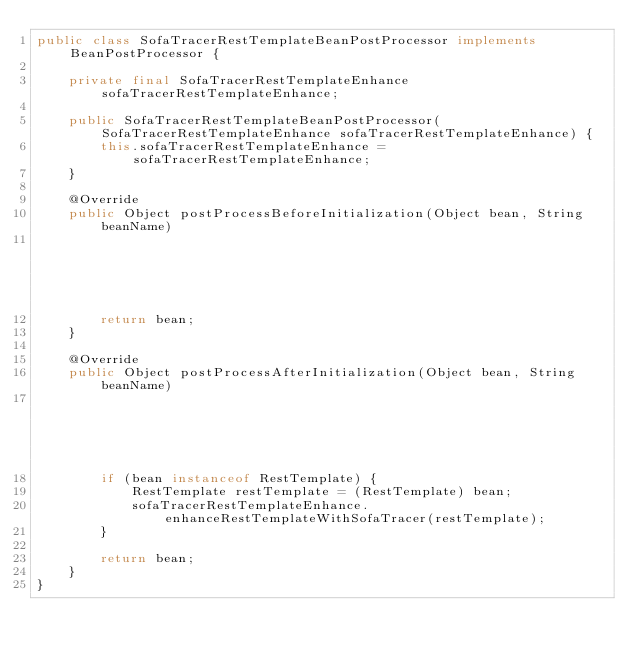Convert code to text. <code><loc_0><loc_0><loc_500><loc_500><_Java_>public class SofaTracerRestTemplateBeanPostProcessor implements BeanPostProcessor {

    private final SofaTracerRestTemplateEnhance sofaTracerRestTemplateEnhance;

    public SofaTracerRestTemplateBeanPostProcessor(SofaTracerRestTemplateEnhance sofaTracerRestTemplateEnhance) {
        this.sofaTracerRestTemplateEnhance = sofaTracerRestTemplateEnhance;
    }

    @Override
    public Object postProcessBeforeInitialization(Object bean, String beanName)
                                                                               throws BeansException {
        return bean;
    }

    @Override
    public Object postProcessAfterInitialization(Object bean, String beanName)
                                                                              throws BeansException {
        if (bean instanceof RestTemplate) {
            RestTemplate restTemplate = (RestTemplate) bean;
            sofaTracerRestTemplateEnhance.enhanceRestTemplateWithSofaTracer(restTemplate);
        }

        return bean;
    }
}
</code> 